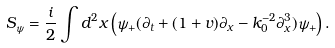<formula> <loc_0><loc_0><loc_500><loc_500>S _ { \psi } = \frac { i } { 2 } \int d ^ { 2 } x \left ( \psi _ { + } ( \partial _ { t } + ( 1 + v ) \partial _ { x } - k _ { 0 } ^ { - 2 } \partial _ { x } ^ { 3 } ) \psi _ { + } \right ) .</formula> 